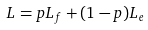Convert formula to latex. <formula><loc_0><loc_0><loc_500><loc_500>L = p L _ { f } + ( 1 - p ) L _ { e }</formula> 